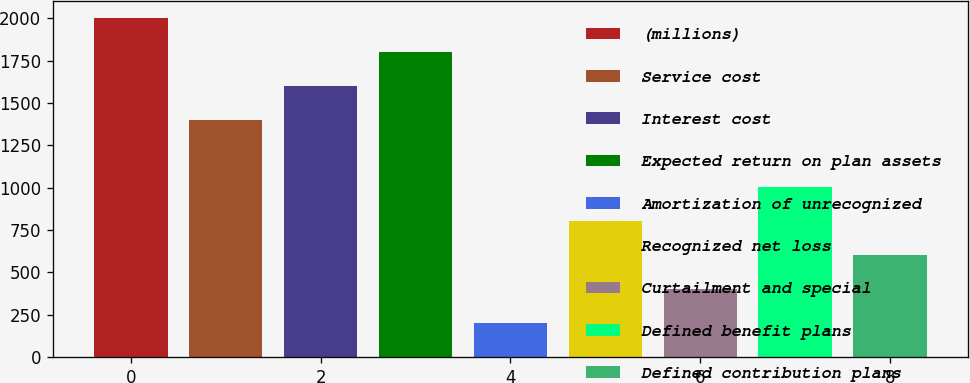Convert chart. <chart><loc_0><loc_0><loc_500><loc_500><bar_chart><fcel>(millions)<fcel>Service cost<fcel>Interest cost<fcel>Expected return on plan assets<fcel>Amortization of unrecognized<fcel>Recognized net loss<fcel>Curtailment and special<fcel>Defined benefit plans<fcel>Defined contribution plans<nl><fcel>2003<fcel>1402.13<fcel>1602.42<fcel>1802.71<fcel>200.39<fcel>801.26<fcel>400.68<fcel>1001.55<fcel>600.97<nl></chart> 